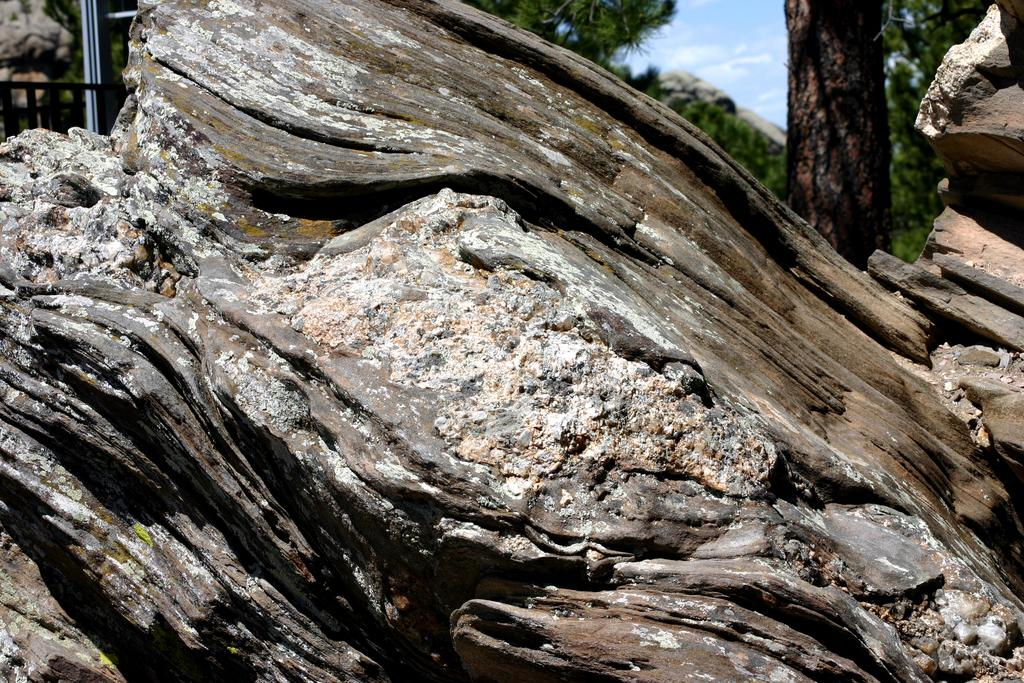What is the main subject in the image? There is a part of a tree in the image. What else can be seen on the left side of the image? There is a pole on the left side of the image. What is visible in the background of the image? There are trees and clouds in the sky in the background of the image. What type of trousers is the tree wearing in the image? Trees do not wear trousers, as they are not human or capable of wearing clothing. 